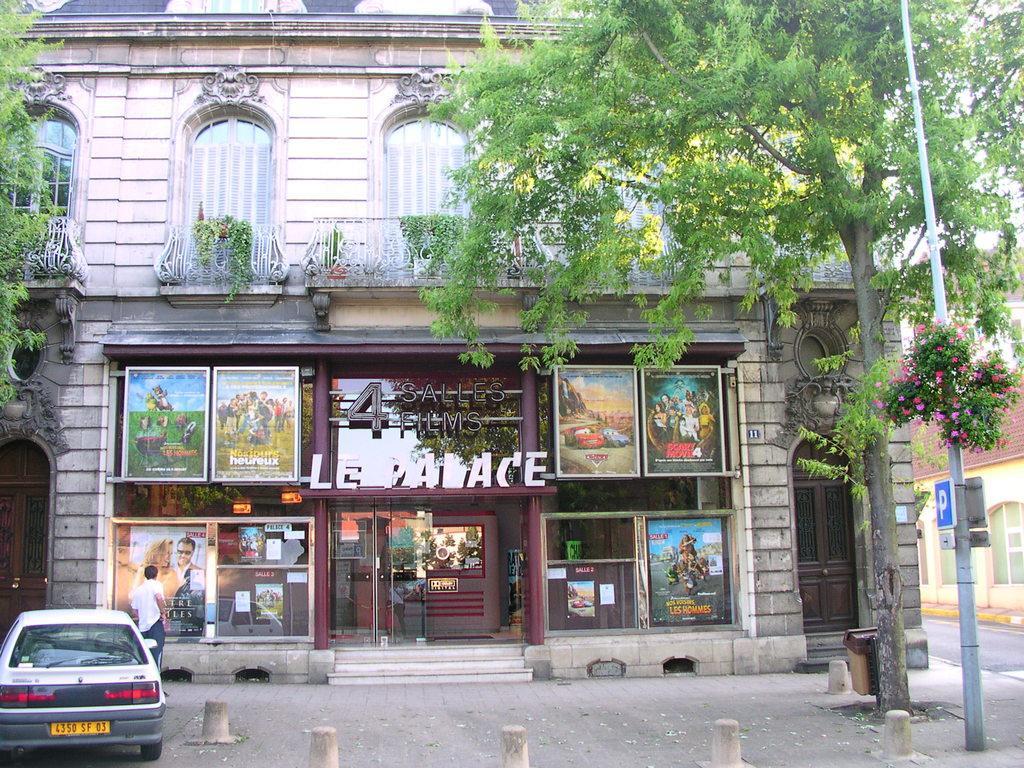Please provide a concise description of this image. There is a car and a person is in the bottom left corner of this image. We can see trees on the right side of this image and on the left side of this image as well. There is a building in the middle of this image. There is a pole on the right side of this image. 